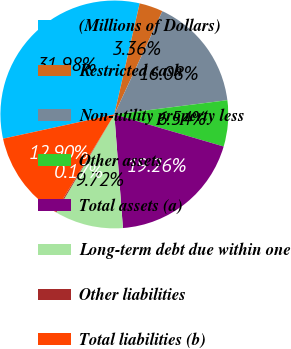<chart> <loc_0><loc_0><loc_500><loc_500><pie_chart><fcel>(Millions of Dollars)<fcel>Restricted cash<fcel>Non-utility property less<fcel>Other assets<fcel>Total assets (a)<fcel>Long-term debt due within one<fcel>Other liabilities<fcel>Total liabilities (b)<nl><fcel>31.98%<fcel>3.36%<fcel>16.08%<fcel>6.54%<fcel>19.26%<fcel>9.72%<fcel>0.17%<fcel>12.9%<nl></chart> 